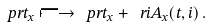<formula> <loc_0><loc_0><loc_500><loc_500>\ p r t _ { x } \longmapsto \ p r t _ { x } + \ r i A _ { x } ( t , i ) \, .</formula> 